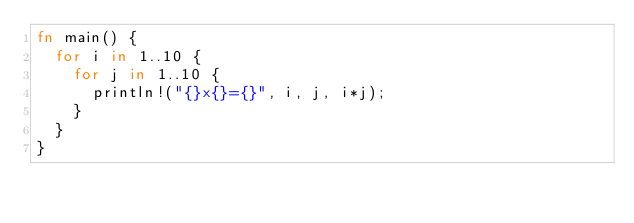<code> <loc_0><loc_0><loc_500><loc_500><_Rust_>fn main() {
  for i in 1..10 {
    for j in 1..10 {
      println!("{}x{}={}", i, j, i*j);
    }
  }
}

</code> 